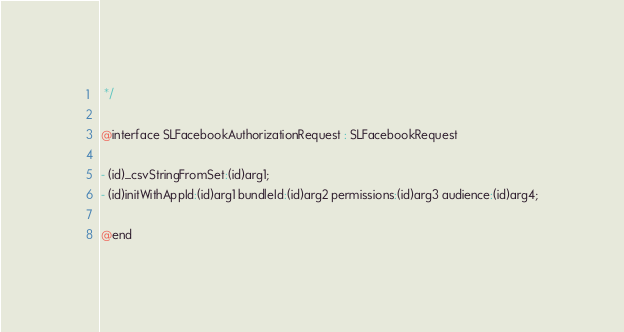<code> <loc_0><loc_0><loc_500><loc_500><_C_> */

@interface SLFacebookAuthorizationRequest : SLFacebookRequest

- (id)_csvStringFromSet:(id)arg1;
- (id)initWithAppId:(id)arg1 bundleId:(id)arg2 permissions:(id)arg3 audience:(id)arg4;

@end
</code> 